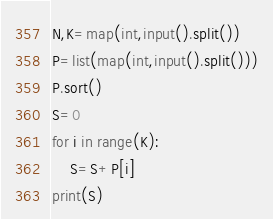Convert code to text. <code><loc_0><loc_0><loc_500><loc_500><_Python_>N,K=map(int,input().split())
P=list(map(int,input().split()))
P.sort()
S=0
for i in range(K):
	S=S+P[i]
print(S)</code> 